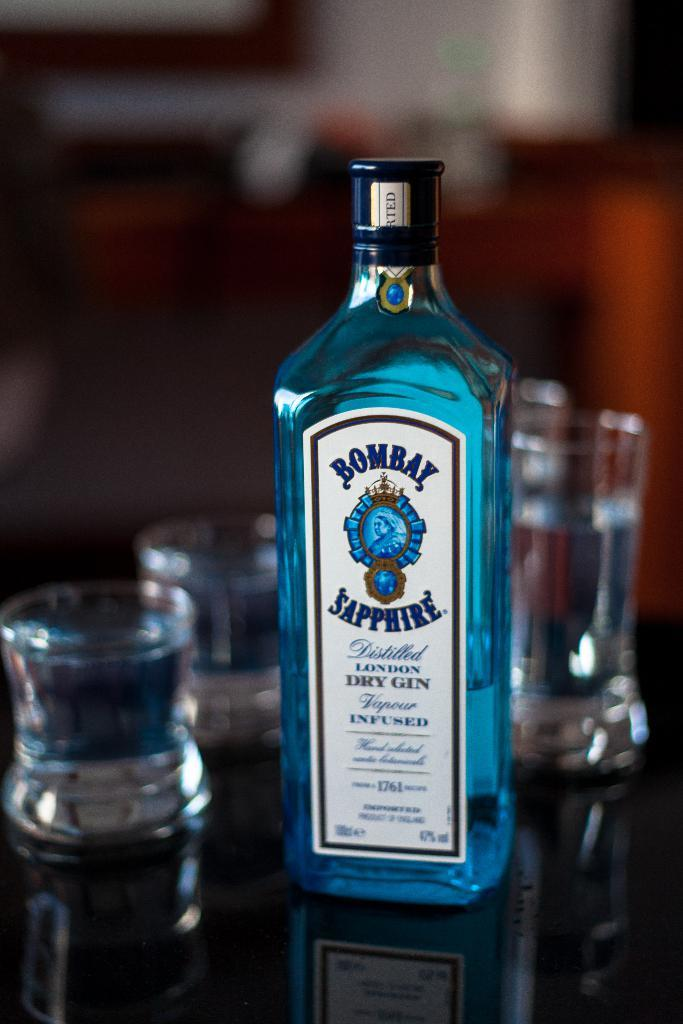<image>
Provide a brief description of the given image. A bottle of Bombay Sapphire gin sits next to two small and two tall glasses. 